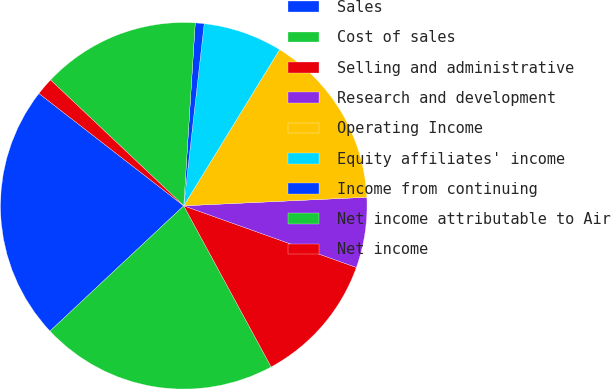Convert chart to OTSL. <chart><loc_0><loc_0><loc_500><loc_500><pie_chart><fcel>Sales<fcel>Cost of sales<fcel>Selling and administrative<fcel>Research and development<fcel>Operating Income<fcel>Equity affiliates' income<fcel>Income from continuing<fcel>Net income attributable to Air<fcel>Net income<nl><fcel>22.48%<fcel>20.93%<fcel>11.63%<fcel>6.2%<fcel>15.5%<fcel>6.98%<fcel>0.78%<fcel>13.95%<fcel>1.55%<nl></chart> 